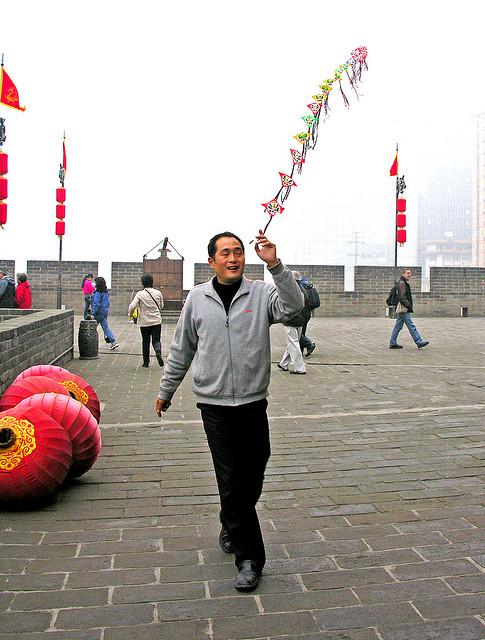Is this in China?
Short answer required. Yes. Is this an illusion?
Keep it brief. Yes. Is this man being paid to entertain?
Write a very short answer. No. 